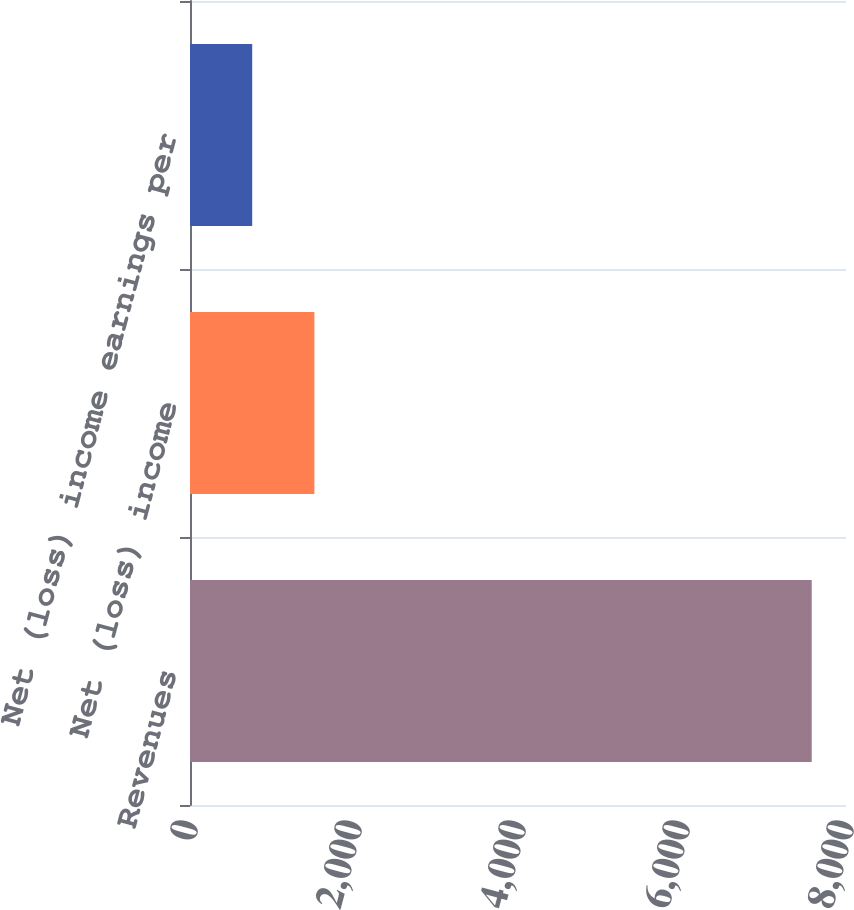Convert chart to OTSL. <chart><loc_0><loc_0><loc_500><loc_500><bar_chart><fcel>Revenues<fcel>Net (loss) income<fcel>Net (loss) income earnings per<nl><fcel>7582<fcel>1516.73<fcel>758.57<nl></chart> 